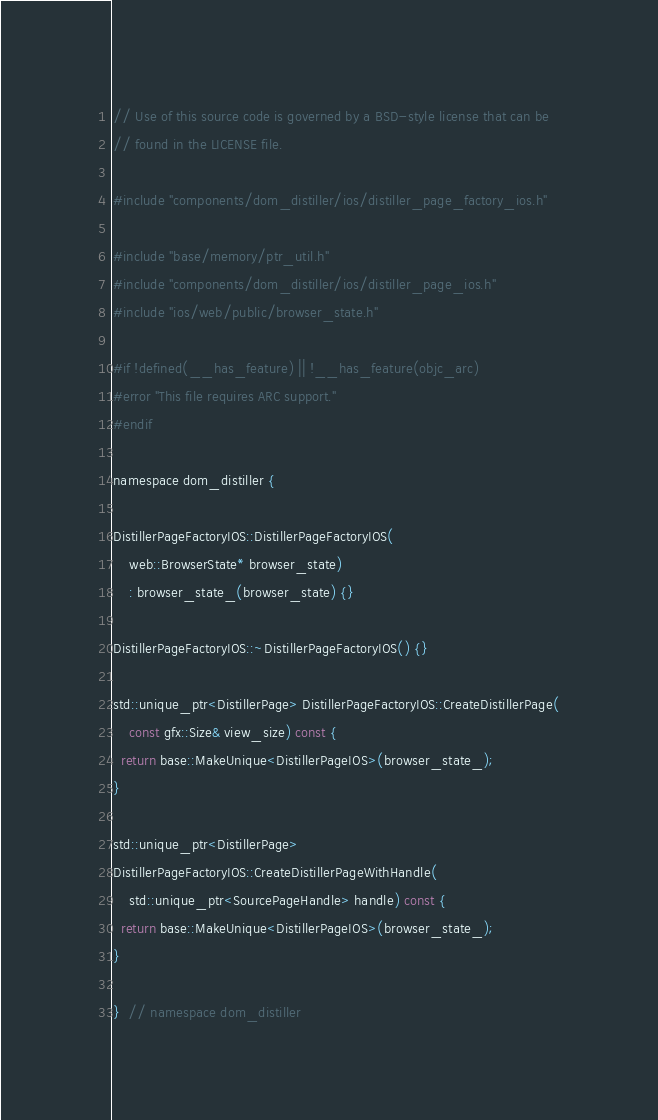<code> <loc_0><loc_0><loc_500><loc_500><_ObjectiveC_>// Use of this source code is governed by a BSD-style license that can be
// found in the LICENSE file.

#include "components/dom_distiller/ios/distiller_page_factory_ios.h"

#include "base/memory/ptr_util.h"
#include "components/dom_distiller/ios/distiller_page_ios.h"
#include "ios/web/public/browser_state.h"

#if !defined(__has_feature) || !__has_feature(objc_arc)
#error "This file requires ARC support."
#endif

namespace dom_distiller {

DistillerPageFactoryIOS::DistillerPageFactoryIOS(
    web::BrowserState* browser_state)
    : browser_state_(browser_state) {}

DistillerPageFactoryIOS::~DistillerPageFactoryIOS() {}

std::unique_ptr<DistillerPage> DistillerPageFactoryIOS::CreateDistillerPage(
    const gfx::Size& view_size) const {
  return base::MakeUnique<DistillerPageIOS>(browser_state_);
}

std::unique_ptr<DistillerPage>
DistillerPageFactoryIOS::CreateDistillerPageWithHandle(
    std::unique_ptr<SourcePageHandle> handle) const {
  return base::MakeUnique<DistillerPageIOS>(browser_state_);
}

}  // namespace dom_distiller
</code> 